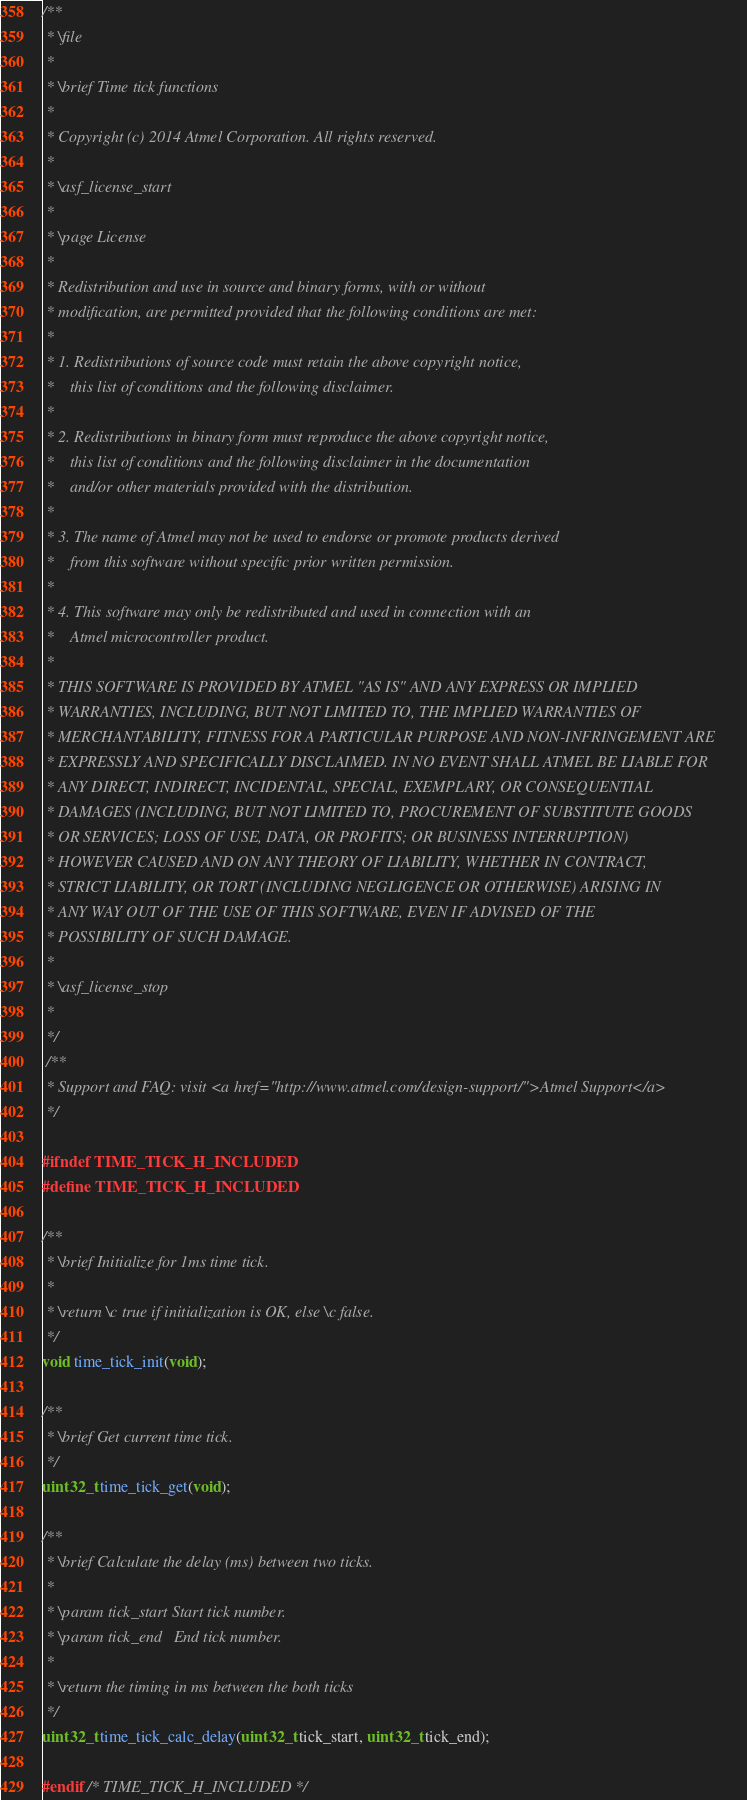Convert code to text. <code><loc_0><loc_0><loc_500><loc_500><_C_>/**
 * \file
 *
 * \brief Time tick functions
 *
 * Copyright (c) 2014 Atmel Corporation. All rights reserved.
 *
 * \asf_license_start
 *
 * \page License
 *
 * Redistribution and use in source and binary forms, with or without
 * modification, are permitted provided that the following conditions are met:
 *
 * 1. Redistributions of source code must retain the above copyright notice,
 *    this list of conditions and the following disclaimer.
 *
 * 2. Redistributions in binary form must reproduce the above copyright notice,
 *    this list of conditions and the following disclaimer in the documentation
 *    and/or other materials provided with the distribution.
 *
 * 3. The name of Atmel may not be used to endorse or promote products derived
 *    from this software without specific prior written permission.
 *
 * 4. This software may only be redistributed and used in connection with an
 *    Atmel microcontroller product.
 *
 * THIS SOFTWARE IS PROVIDED BY ATMEL "AS IS" AND ANY EXPRESS OR IMPLIED
 * WARRANTIES, INCLUDING, BUT NOT LIMITED TO, THE IMPLIED WARRANTIES OF
 * MERCHANTABILITY, FITNESS FOR A PARTICULAR PURPOSE AND NON-INFRINGEMENT ARE
 * EXPRESSLY AND SPECIFICALLY DISCLAIMED. IN NO EVENT SHALL ATMEL BE LIABLE FOR
 * ANY DIRECT, INDIRECT, INCIDENTAL, SPECIAL, EXEMPLARY, OR CONSEQUENTIAL
 * DAMAGES (INCLUDING, BUT NOT LIMITED TO, PROCUREMENT OF SUBSTITUTE GOODS
 * OR SERVICES; LOSS OF USE, DATA, OR PROFITS; OR BUSINESS INTERRUPTION)
 * HOWEVER CAUSED AND ON ANY THEORY OF LIABILITY, WHETHER IN CONTRACT,
 * STRICT LIABILITY, OR TORT (INCLUDING NEGLIGENCE OR OTHERWISE) ARISING IN
 * ANY WAY OUT OF THE USE OF THIS SOFTWARE, EVEN IF ADVISED OF THE
 * POSSIBILITY OF SUCH DAMAGE.
 *
 * \asf_license_stop
 *
 */
 /**
 * Support and FAQ: visit <a href="http://www.atmel.com/design-support/">Atmel Support</a>
 */

#ifndef TIME_TICK_H_INCLUDED
#define TIME_TICK_H_INCLUDED

/**
 * \brief Initialize for 1ms time tick.
 *
 * \return \c true if initialization is OK, else \c false.
 */
void time_tick_init(void);

/**
 * \brief Get current time tick.
 */
uint32_t time_tick_get(void);

/**
 * \brief Calculate the delay (ms) between two ticks.
 *
 * \param tick_start Start tick number.
 * \param tick_end   End tick number.
 *
 * \return the timing in ms between the both ticks
 */
uint32_t time_tick_calc_delay(uint32_t tick_start, uint32_t tick_end);

#endif /* TIME_TICK_H_INCLUDED */
</code> 